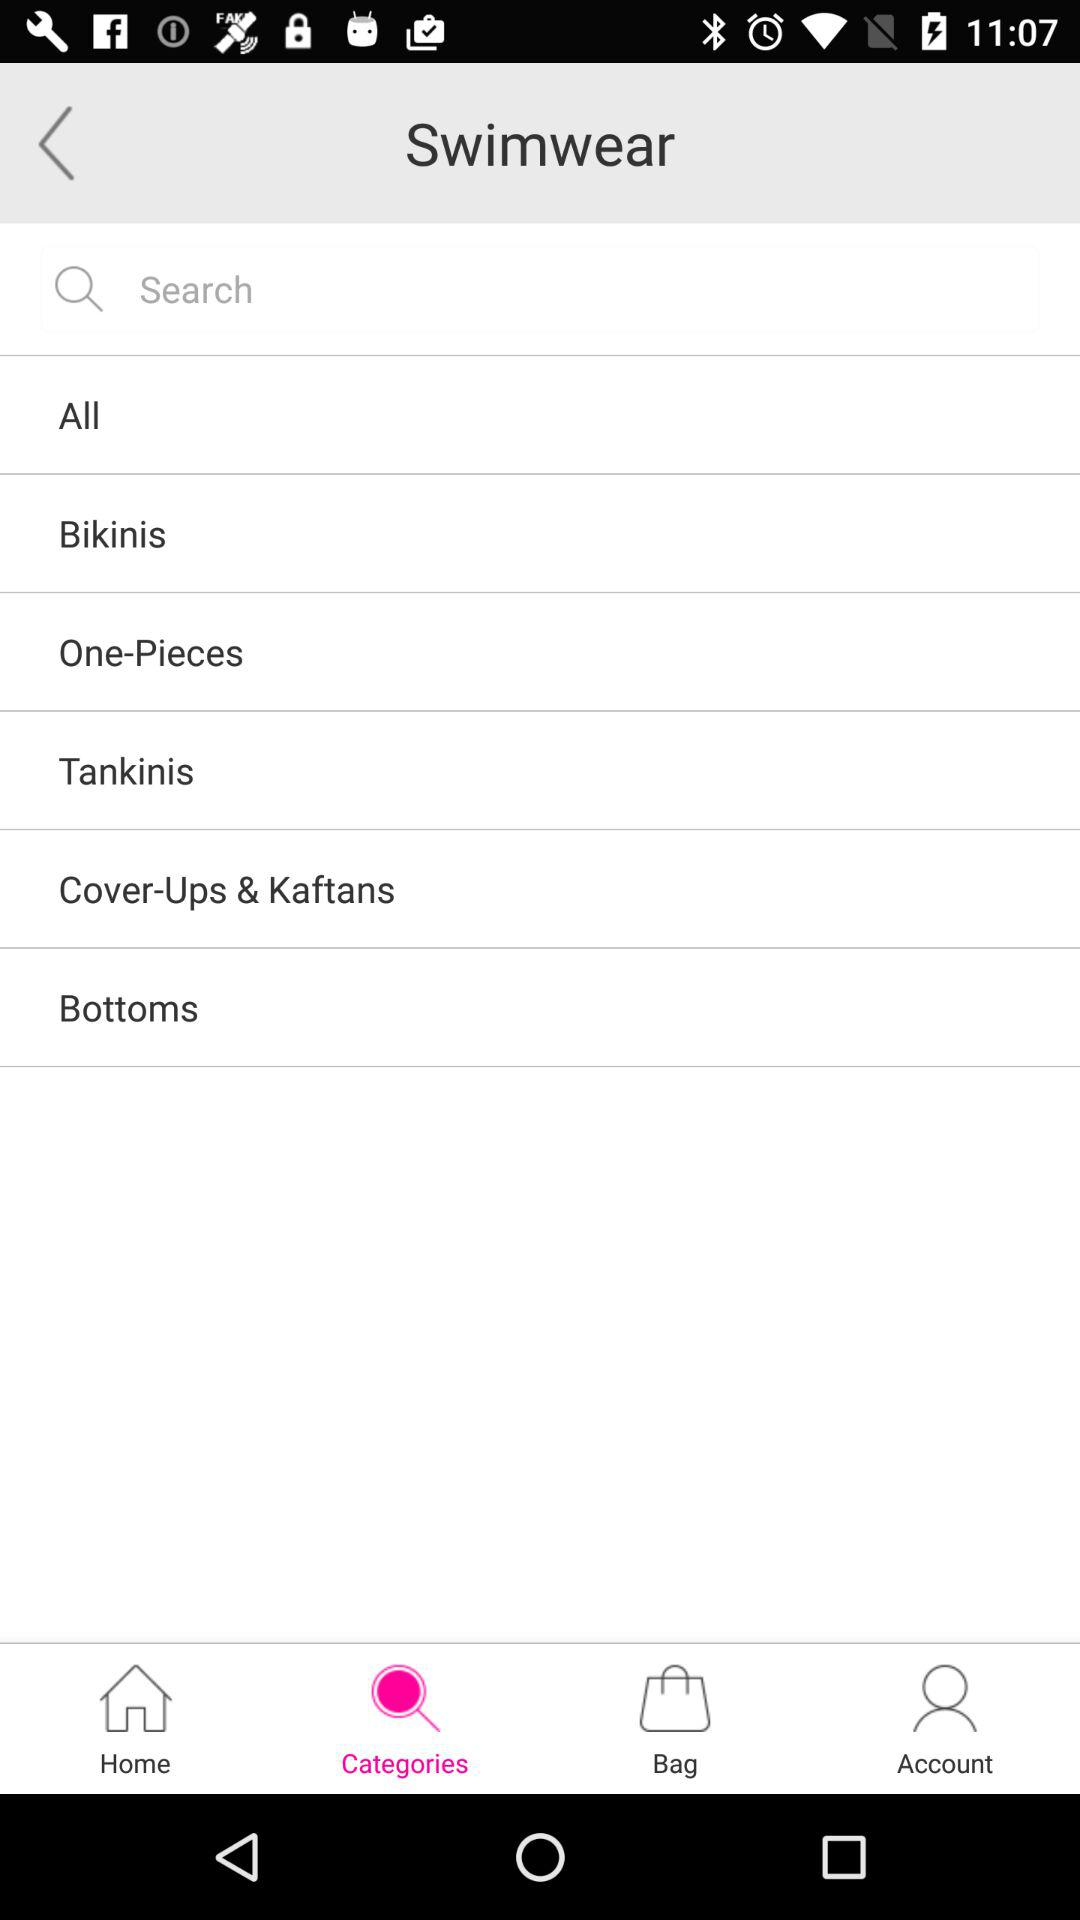Which tab is selected? The selected tab is "Categories". 